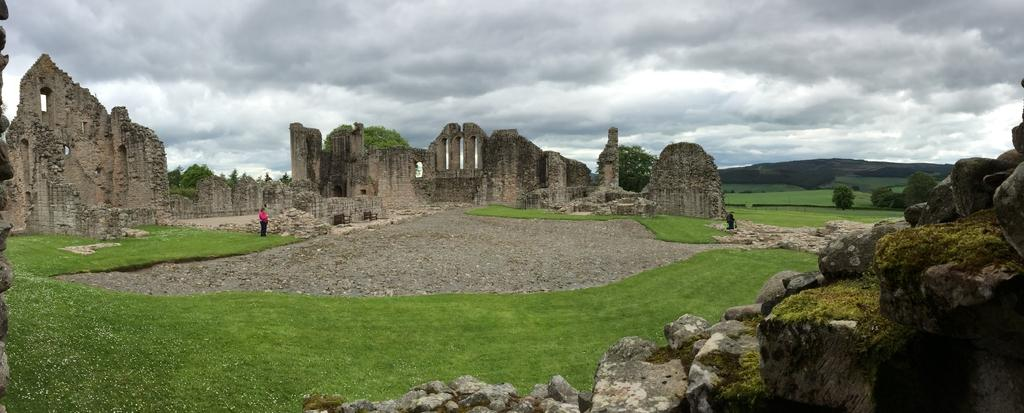What type of structures are in the center of the image? There are stone architectures in the center of the image. What can be seen at the bottom of the image? There is grass and stones at the bottom of the image. Can you describe the person's position in the image? There is a person towards the left of the image. What is visible in the sky at the top of the image? There is a sky with clouds visible at the top of the image. How many stamps are on the person's forehead in the image? There are no stamps visible on the person's forehead in the image. What type of error can be seen in the stone architectures? There is no error present in the stone architectures in the image. 